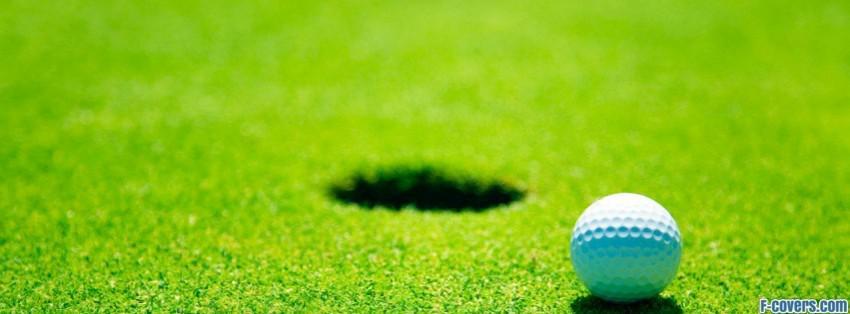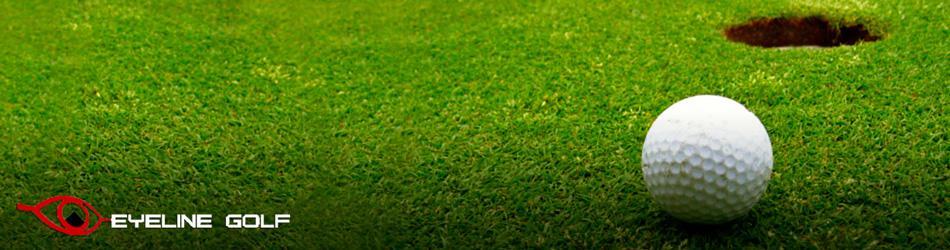The first image is the image on the left, the second image is the image on the right. For the images shown, is this caption "A golf ball is on a tee in one image." true? Answer yes or no. No. The first image is the image on the left, the second image is the image on the right. Evaluate the accuracy of this statement regarding the images: "At least one of the balls is sitting near the hole.". Is it true? Answer yes or no. Yes. 